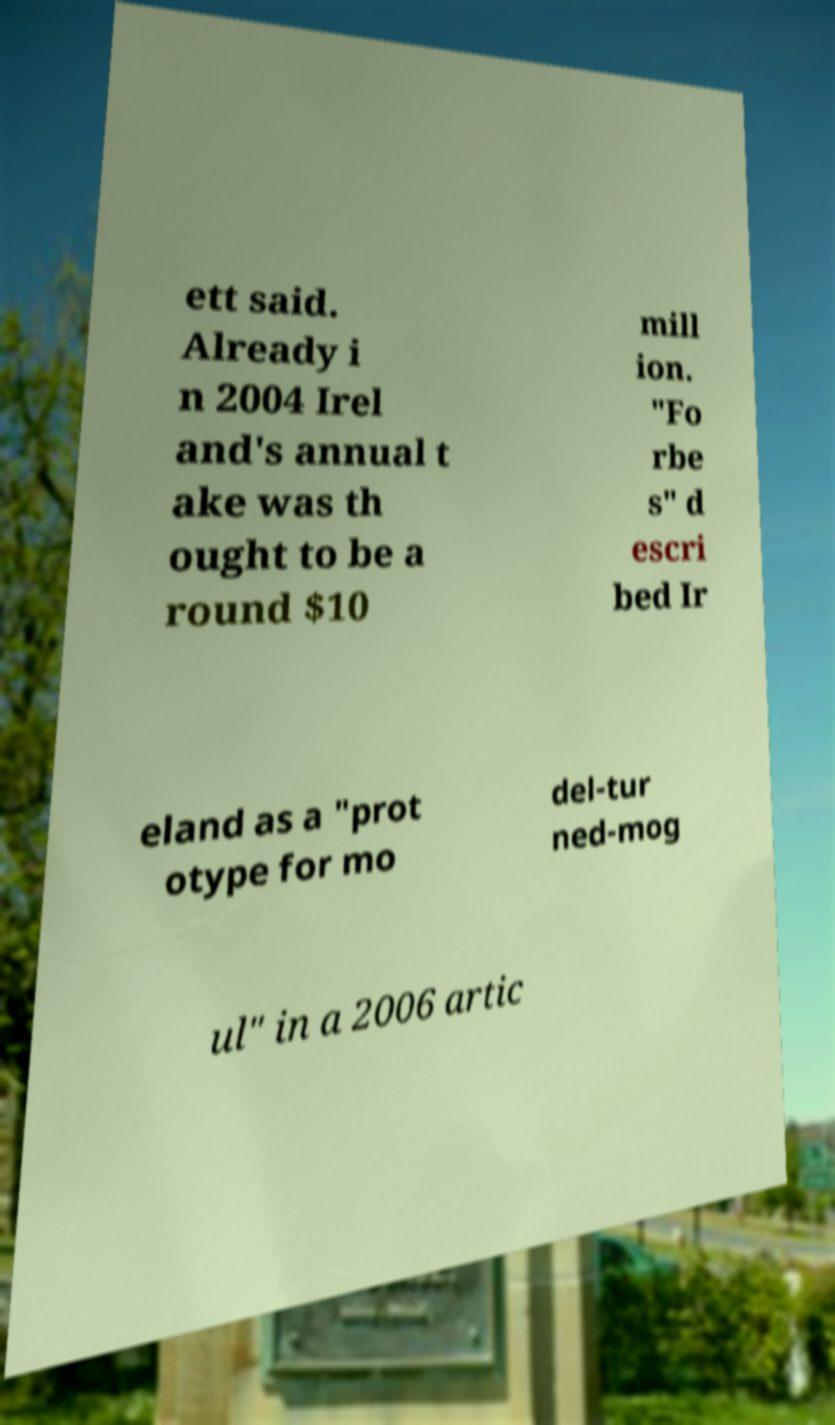For documentation purposes, I need the text within this image transcribed. Could you provide that? ett said. Already i n 2004 Irel and's annual t ake was th ought to be a round $10 mill ion. "Fo rbe s" d escri bed Ir eland as a "prot otype for mo del-tur ned-mog ul" in a 2006 artic 